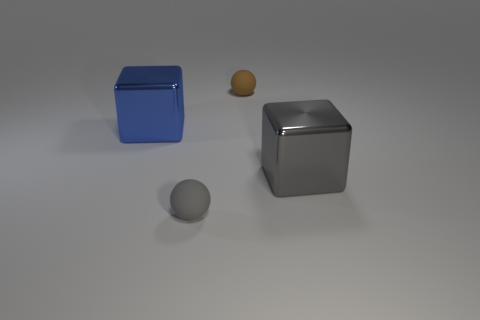Add 3 gray cubes. How many objects exist? 7 Subtract 0 green cylinders. How many objects are left? 4 Subtract all brown matte spheres. Subtract all big gray blocks. How many objects are left? 2 Add 1 gray things. How many gray things are left? 3 Add 2 big gray spheres. How many big gray spheres exist? 2 